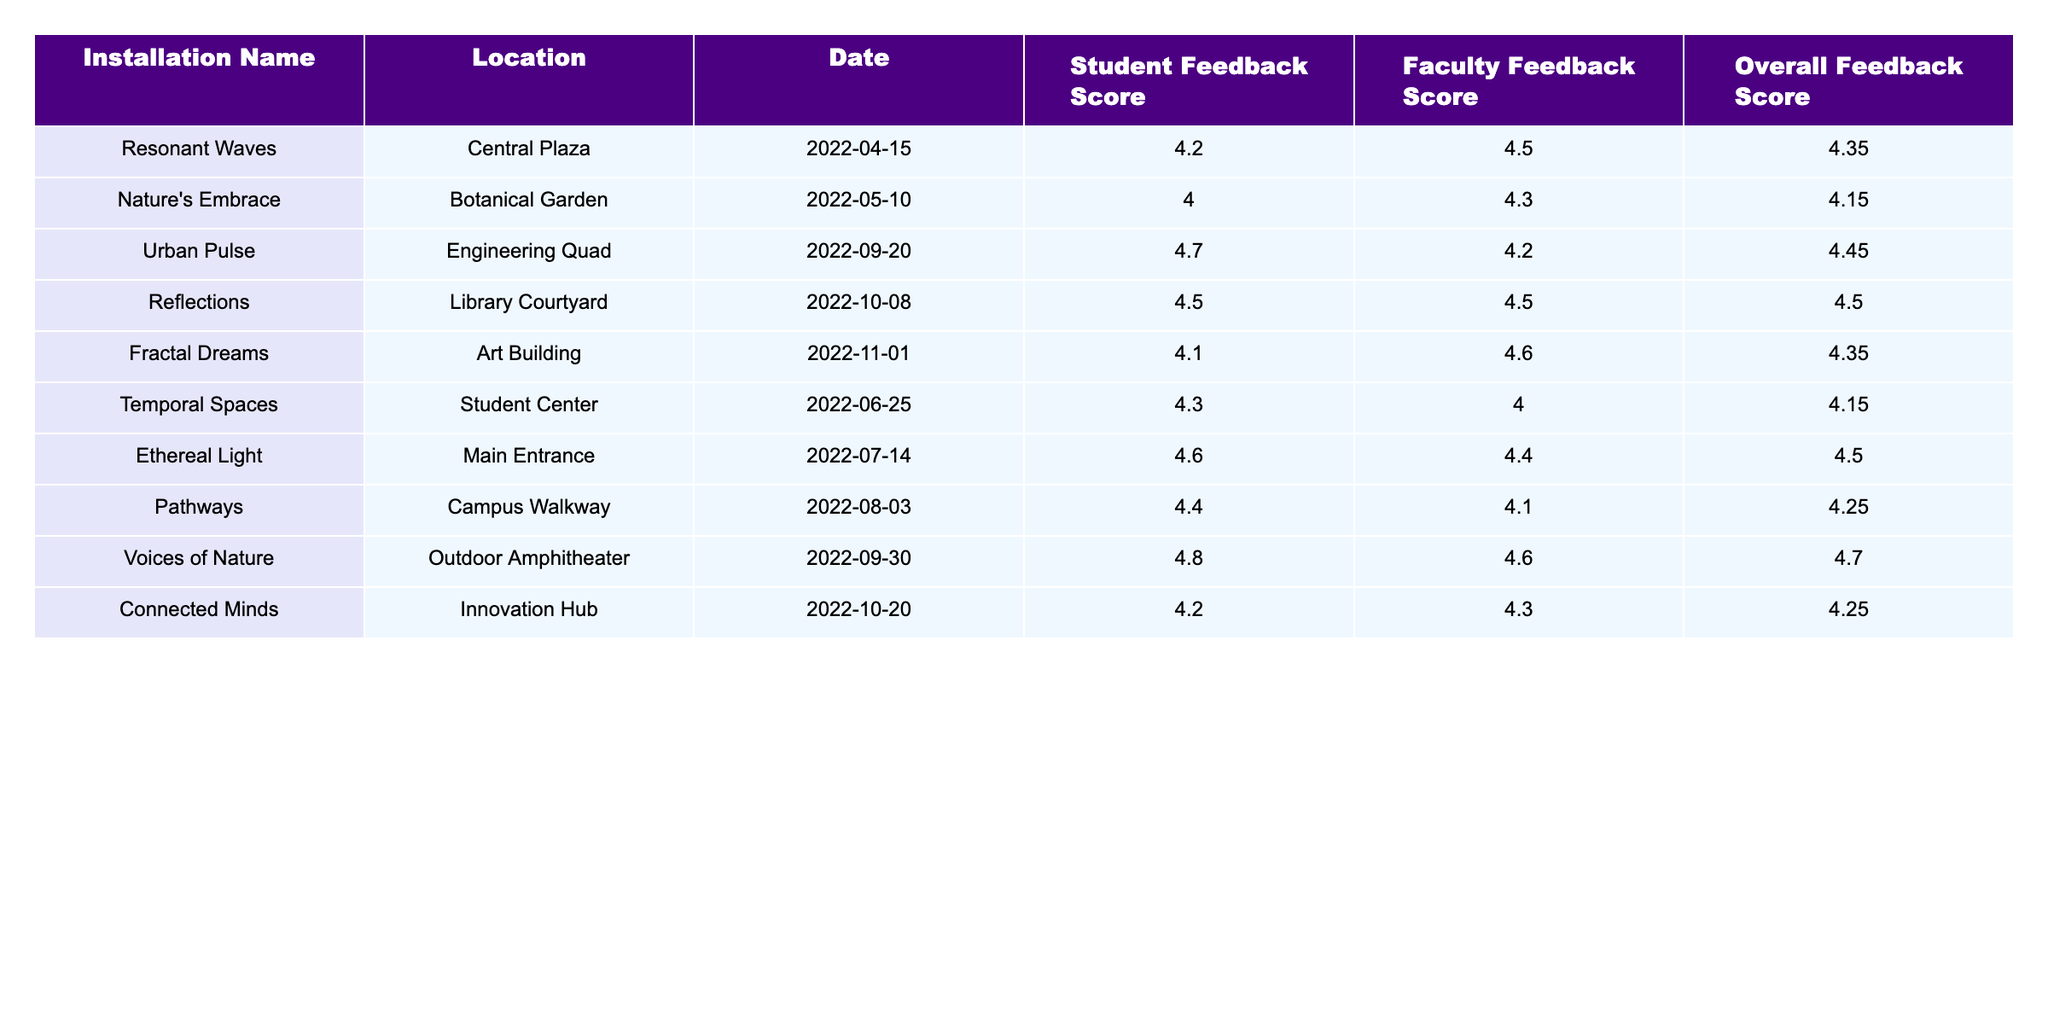What was the highest Student Feedback Score among the installations? The highest Student Feedback Score in the table is 4.8, given to the installation "Voices of Nature."
Answer: 4.8 What is the Overall Feedback Score for "Reflections"? The Overall Feedback Score for "Reflections" is listed directly in the table as 4.50.
Answer: 4.50 Which installation received the lowest Faculty Feedback Score? By reviewing the Faculty Feedback Scores in the table, the installation "Temporal Spaces" has the lowest score at 4.0.
Answer: 4.0 What is the average Student Feedback Score for all installations? To calculate the average, sum the Student Feedback Scores (4.2 + 4.0 + 4.7 + 4.5 + 4.1 + 4.3 + 4.6 + 4.4 + 4.8 + 4.2 = 44.8) and divide by the number of installations (10), which gives an average of 4.48.
Answer: 4.48 Did "Ethereal Light" have a higher Faculty Feedback Score than "Connected Minds"? The Faculty Feedback Score for "Ethereal Light" is 4.4, while for "Connected Minds" it is 4.3. Since 4.4 is greater than 4.3, the statement is true.
Answer: Yes What is the difference between the highest and lowest Overall Feedback Score? The highest Overall Feedback Score is 4.70 (for "Voices of Nature") and the lowest is 4.15 (for "Nature's Embrace" and "Temporal Spaces"). The difference is 4.70 - 4.15 = 0.55.
Answer: 0.55 Which locations had an Overall Feedback Score of 4.35? The table shows that "Resonant Waves" and "Fractal Dreams" both had an Overall Feedback Score of 4.35.
Answer: "Resonant Waves" and "Fractal Dreams" What is the overall average Faculty Feedback Score? First, sum all Faculty Feedback Scores (4.5 + 4.3 + 4.2 + 4.5 + 4.6 + 4.0 + 4.4 + 4.1 + 4.6 + 4.3 = 44.2), then divide by the number of installations (10). The average is 44.2 / 10 = 4.42.
Answer: 4.42 Was there an installation at the Main Entrance? Yes, the installation "Ethereal Light" was located at the Main Entrance, as indicated in the table.
Answer: Yes Which installation received the highest Overall Feedback Score, and what was the score? The installation with the highest Overall Feedback Score is "Voices of Nature," which received a score of 4.70.
Answer: "Voices of Nature", 4.70 